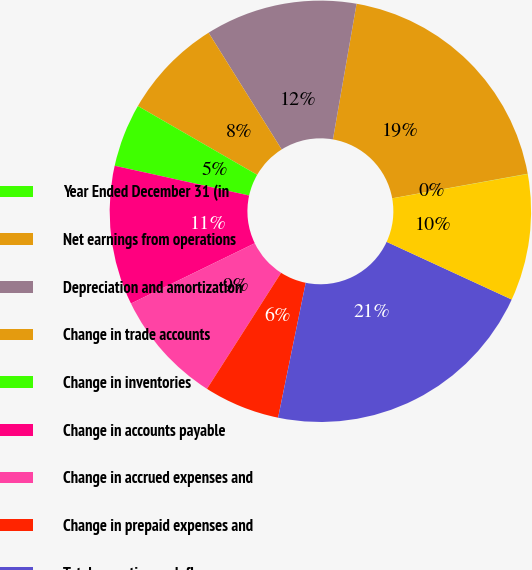Convert chart. <chart><loc_0><loc_0><loc_500><loc_500><pie_chart><fcel>Year Ended December 31 (in<fcel>Net earnings from operations<fcel>Depreciation and amortization<fcel>Change in trade accounts<fcel>Change in inventories<fcel>Change in accounts payable<fcel>Change in accrued expenses and<fcel>Change in prepaid expenses and<fcel>Total operating cash flows<fcel>Payments for additions to<nl><fcel>0.02%<fcel>19.4%<fcel>11.65%<fcel>7.77%<fcel>4.86%<fcel>10.68%<fcel>8.74%<fcel>5.83%<fcel>21.34%<fcel>9.71%<nl></chart> 